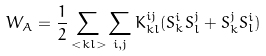Convert formula to latex. <formula><loc_0><loc_0><loc_500><loc_500>W _ { A } = \frac { 1 } { 2 } \sum _ { < k l > } \sum _ { i , j } K ^ { i j } _ { k l } ( S ^ { i } _ { k } S ^ { j } _ { l } + S ^ { j } _ { k } S ^ { i } _ { l } )</formula> 